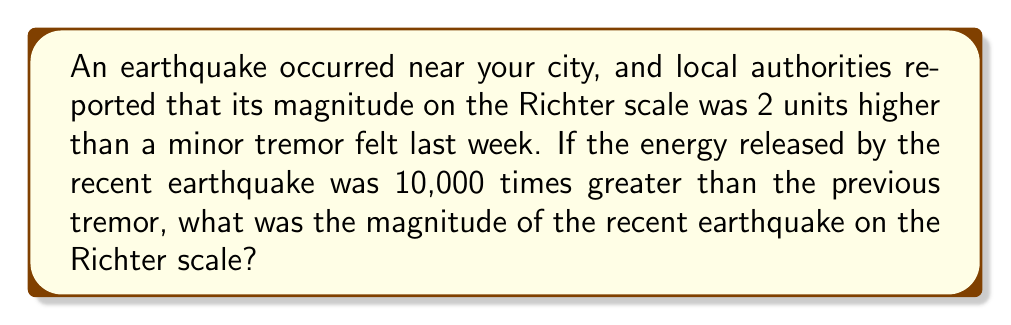Can you answer this question? To solve this problem, we need to understand the relationship between the Richter scale and energy released during an earthquake. The Richter scale is logarithmic, and each whole number increase represents a tenfold increase in the earthquake's amplitude and about a 31.6-fold increase in energy.

Let's approach this step-by-step:

1) Let the magnitude of the previous tremor be $x$ on the Richter scale.

2) The recent earthquake's magnitude is 2 units higher, so it's $x + 2$ on the Richter scale.

3) We know that the energy released by the recent earthquake was 10,000 times greater than the previous tremor.

4) The relationship between energy and magnitude on the Richter scale is given by:

   $\frac{E_2}{E_1} = 10^{1.5(M_2 - M_1)}$

   Where $E_2$ and $E_1$ are the energies, and $M_2$ and $M_1$ are the magnitudes.

5) Plugging in our known values:

   $10,000 = 10^{1.5((x+2) - x)}$

6) Simplify:

   $10,000 = 10^{1.5(2)} = 10^3$

7) This checks out, as $10^4 = 10,000$

8) So, we've confirmed that a 2-unit increase on the Richter scale indeed corresponds to a 10,000-fold increase in energy.

9) To find the actual magnitude of the recent earthquake, we need to consider common Richter scale values. Minor tremors are usually below 3.0, so let's assume the previous tremor was 2.5.

10) If the previous tremor was 2.5, then the recent earthquake would be 2.5 + 2 = 4.5 on the Richter scale.
Answer: The magnitude of the recent earthquake on the Richter scale was 4.5. 